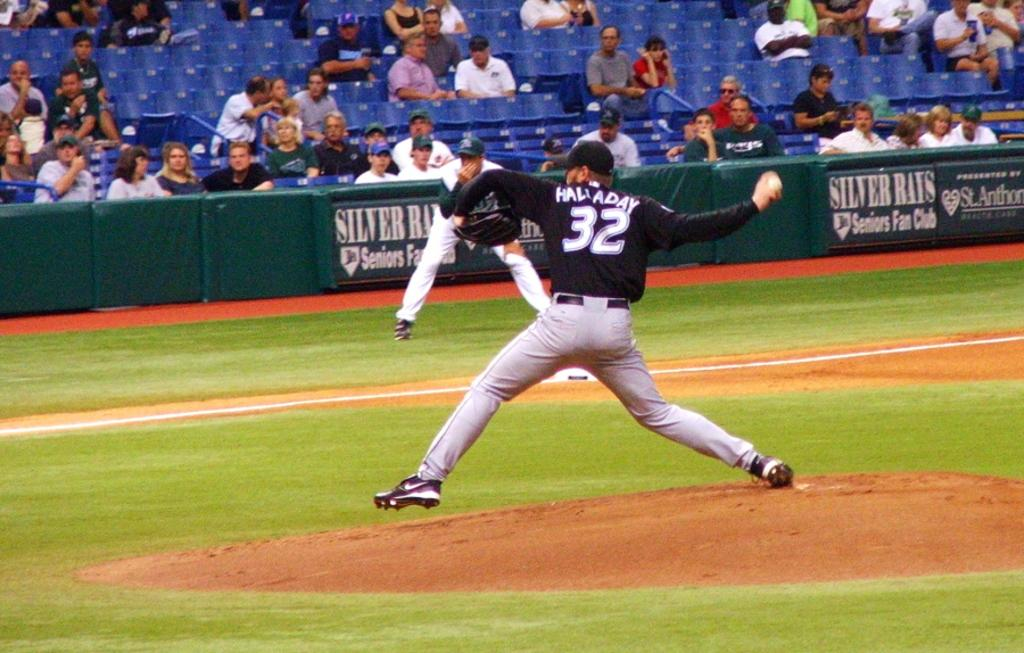<image>
Render a clear and concise summary of the photo. Halladay #32 throws a pitch infront of signs that say Silver Rays Seniors Fan Club. 